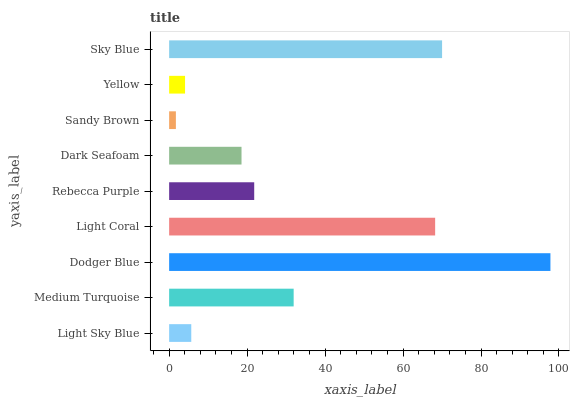Is Sandy Brown the minimum?
Answer yes or no. Yes. Is Dodger Blue the maximum?
Answer yes or no. Yes. Is Medium Turquoise the minimum?
Answer yes or no. No. Is Medium Turquoise the maximum?
Answer yes or no. No. Is Medium Turquoise greater than Light Sky Blue?
Answer yes or no. Yes. Is Light Sky Blue less than Medium Turquoise?
Answer yes or no. Yes. Is Light Sky Blue greater than Medium Turquoise?
Answer yes or no. No. Is Medium Turquoise less than Light Sky Blue?
Answer yes or no. No. Is Rebecca Purple the high median?
Answer yes or no. Yes. Is Rebecca Purple the low median?
Answer yes or no. Yes. Is Medium Turquoise the high median?
Answer yes or no. No. Is Dark Seafoam the low median?
Answer yes or no. No. 